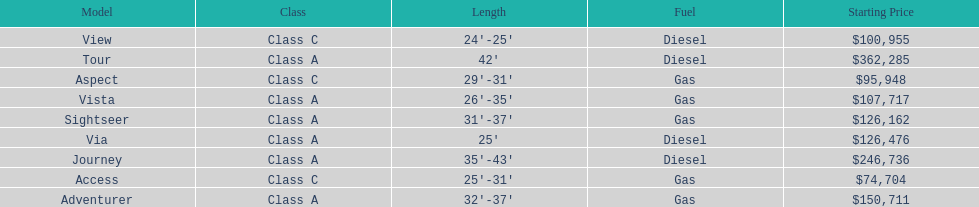How many models are available in lengths longer than 30 feet? 7. 